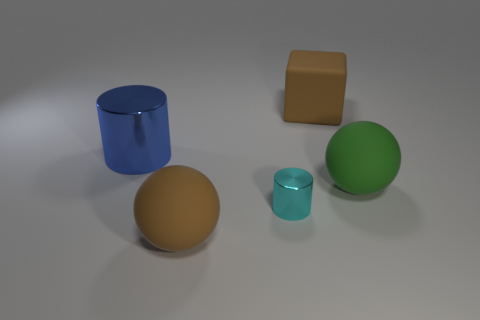Add 2 blue shiny things. How many objects exist? 7 Subtract all blue cylinders. Subtract all purple balls. How many cylinders are left? 1 Subtract all purple blocks. How many cyan cylinders are left? 1 Subtract all big blue metal cylinders. Subtract all brown balls. How many objects are left? 3 Add 2 cyan shiny things. How many cyan shiny things are left? 3 Add 3 tiny red cylinders. How many tiny red cylinders exist? 3 Subtract all green balls. How many balls are left? 1 Subtract 0 purple blocks. How many objects are left? 5 Subtract all cylinders. How many objects are left? 3 Subtract 1 cylinders. How many cylinders are left? 1 